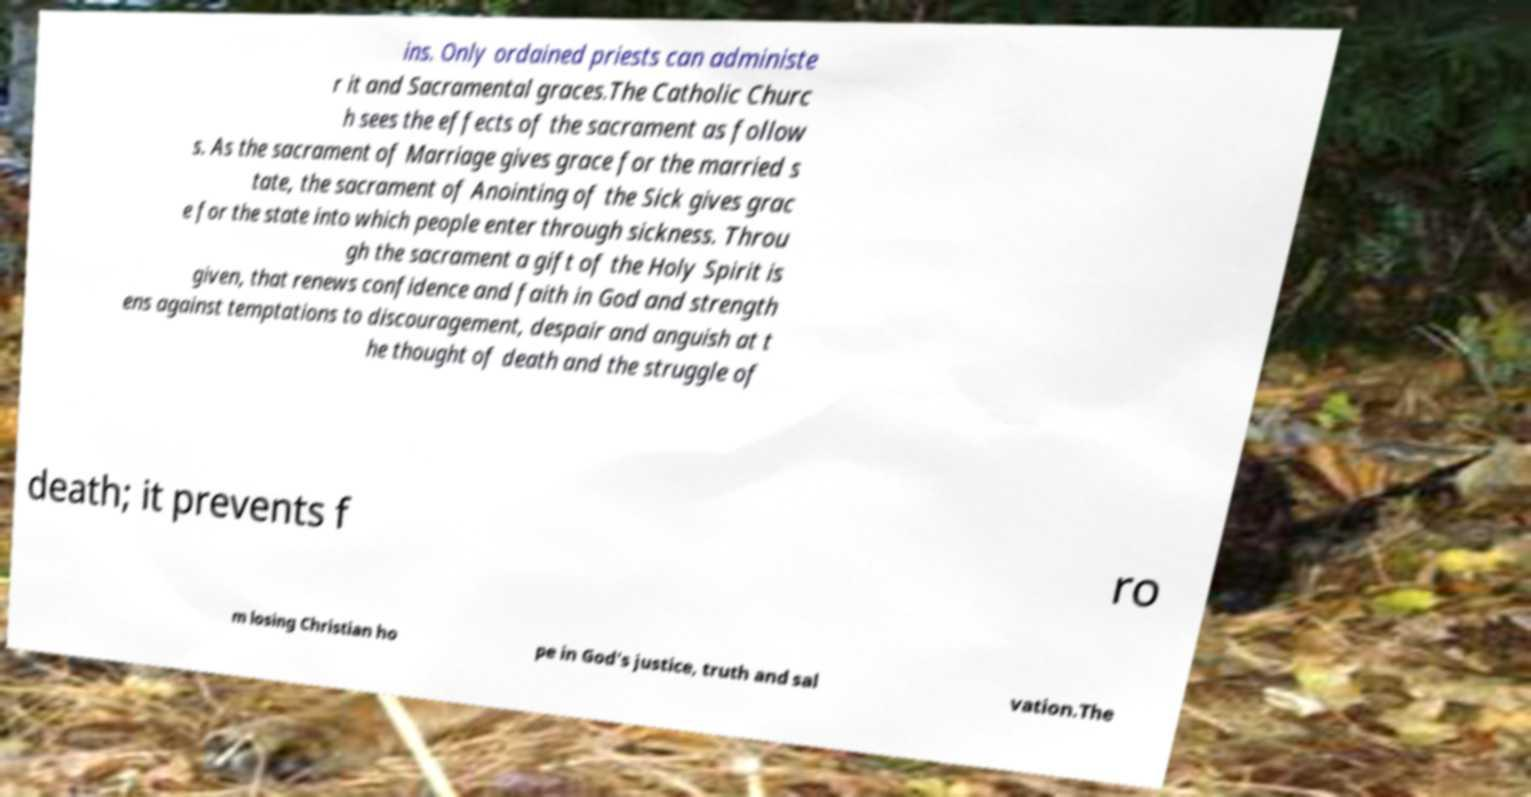There's text embedded in this image that I need extracted. Can you transcribe it verbatim? ins. Only ordained priests can administe r it and Sacramental graces.The Catholic Churc h sees the effects of the sacrament as follow s. As the sacrament of Marriage gives grace for the married s tate, the sacrament of Anointing of the Sick gives grac e for the state into which people enter through sickness. Throu gh the sacrament a gift of the Holy Spirit is given, that renews confidence and faith in God and strength ens against temptations to discouragement, despair and anguish at t he thought of death and the struggle of death; it prevents f ro m losing Christian ho pe in God's justice, truth and sal vation.The 